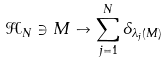Convert formula to latex. <formula><loc_0><loc_0><loc_500><loc_500>\mathcal { H } _ { N } \ni M \to \sum _ { j = 1 } ^ { N } \delta _ { \lambda _ { j } ( M ) }</formula> 